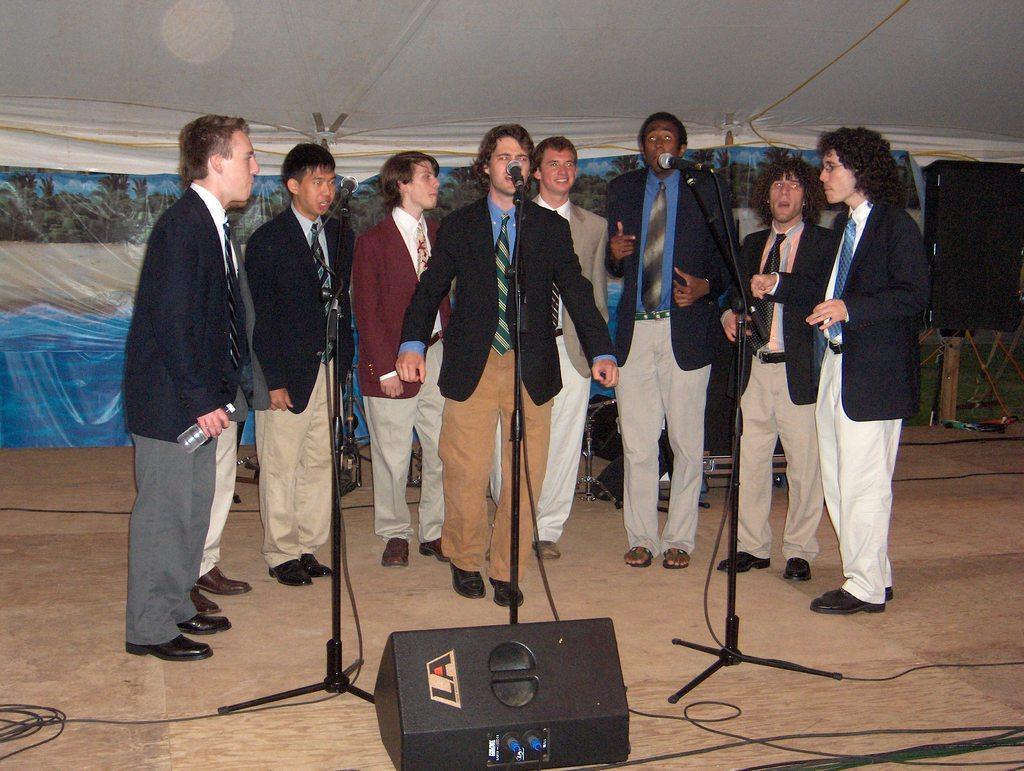Could you give a brief overview of what you see in this image? In the image there are few men in suit standing on stage and singing on mic, behind them there are music instruments and above its a tent. 